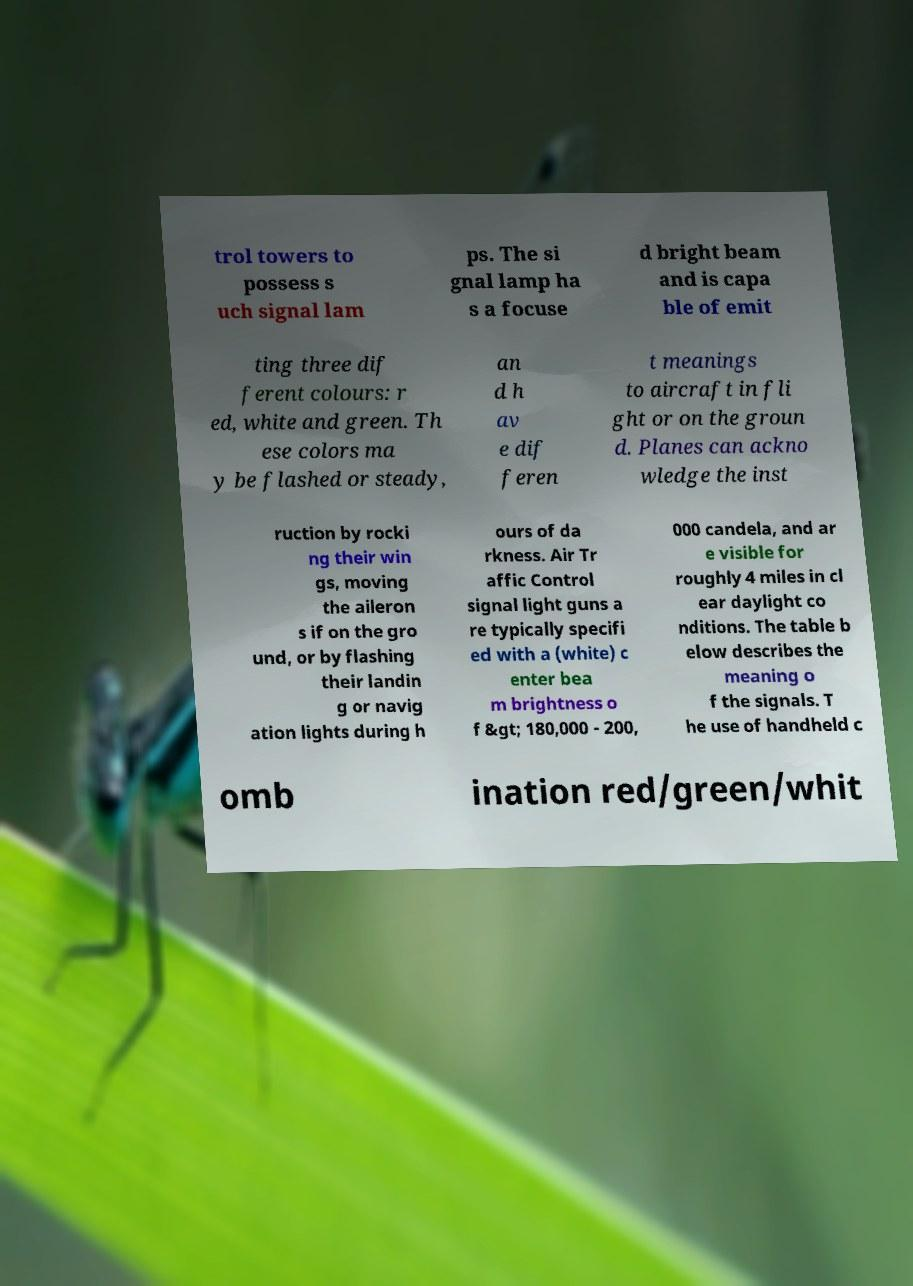What messages or text are displayed in this image? I need them in a readable, typed format. trol towers to possess s uch signal lam ps. The si gnal lamp ha s a focuse d bright beam and is capa ble of emit ting three dif ferent colours: r ed, white and green. Th ese colors ma y be flashed or steady, an d h av e dif feren t meanings to aircraft in fli ght or on the groun d. Planes can ackno wledge the inst ruction by rocki ng their win gs, moving the aileron s if on the gro und, or by flashing their landin g or navig ation lights during h ours of da rkness. Air Tr affic Control signal light guns a re typically specifi ed with a (white) c enter bea m brightness o f &gt; 180,000 - 200, 000 candela, and ar e visible for roughly 4 miles in cl ear daylight co nditions. The table b elow describes the meaning o f the signals. T he use of handheld c omb ination red/green/whit 